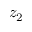Convert formula to latex. <formula><loc_0><loc_0><loc_500><loc_500>z _ { 2 }</formula> 